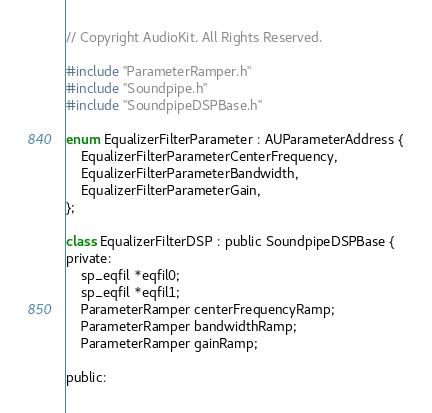Convert code to text. <code><loc_0><loc_0><loc_500><loc_500><_ObjectiveC_>// Copyright AudioKit. All Rights Reserved.

#include "ParameterRamper.h"
#include "Soundpipe.h"
#include "SoundpipeDSPBase.h"

enum EqualizerFilterParameter : AUParameterAddress {
    EqualizerFilterParameterCenterFrequency,
    EqualizerFilterParameterBandwidth,
    EqualizerFilterParameterGain,
};

class EqualizerFilterDSP : public SoundpipeDSPBase {
private:
    sp_eqfil *eqfil0;
    sp_eqfil *eqfil1;
    ParameterRamper centerFrequencyRamp;
    ParameterRamper bandwidthRamp;
    ParameterRamper gainRamp;

public:</code> 